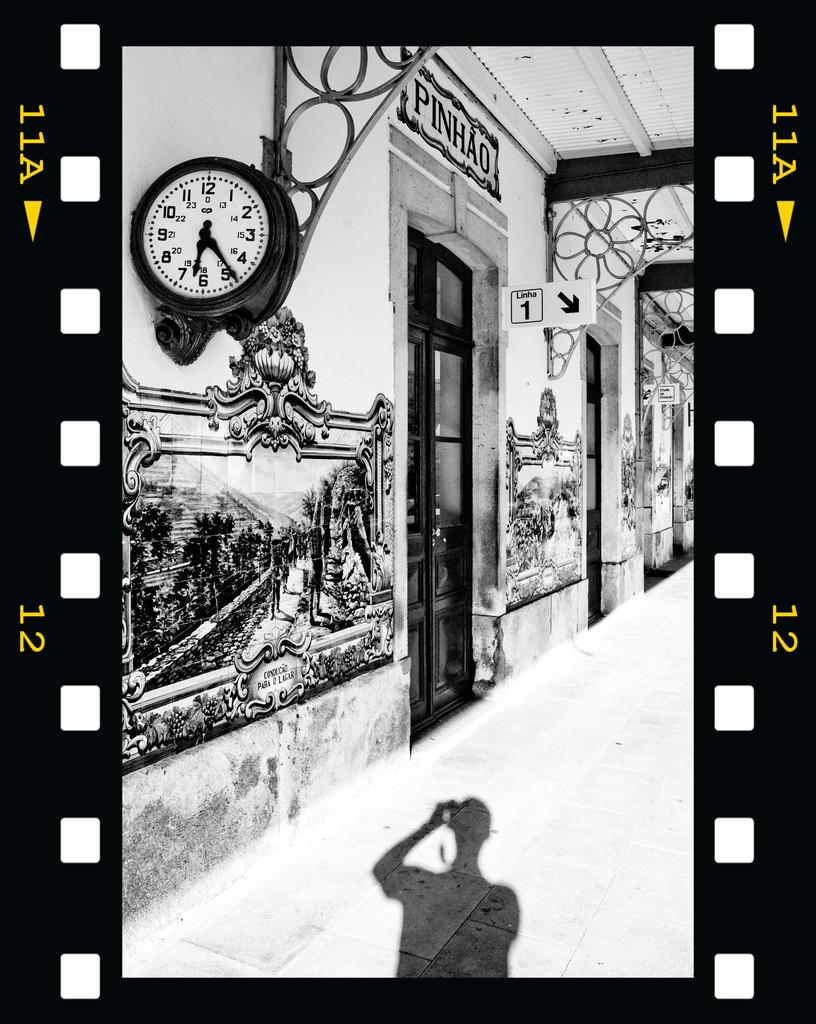<image>
Render a clear and concise summary of the photo. A film reel of a store called PINHAO shows a shadow of a person in front 